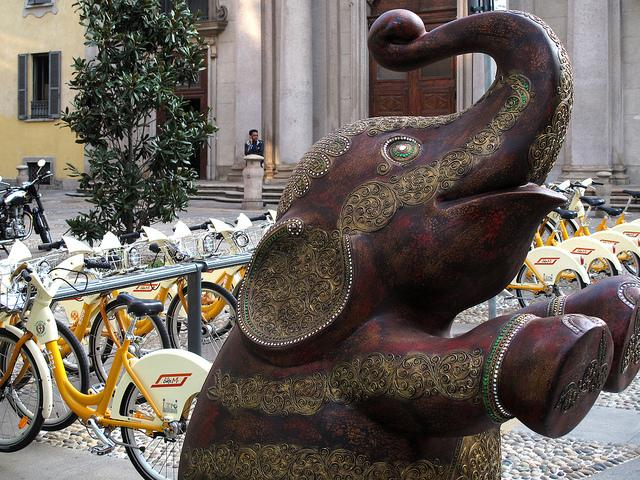The statue best represents who? Please explain your reasoning. ganesh. The statue is ganesh. 